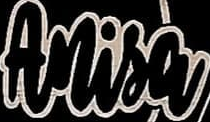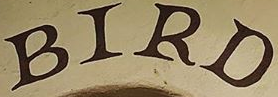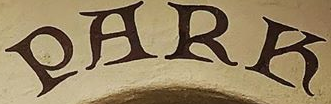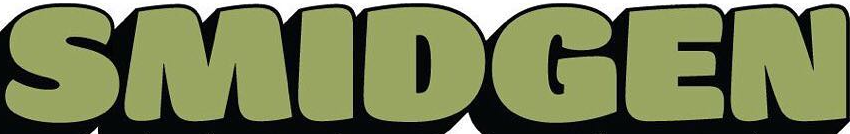What words can you see in these images in sequence, separated by a semicolon? Anisa; BIRD; PARK; SMIDGEN 